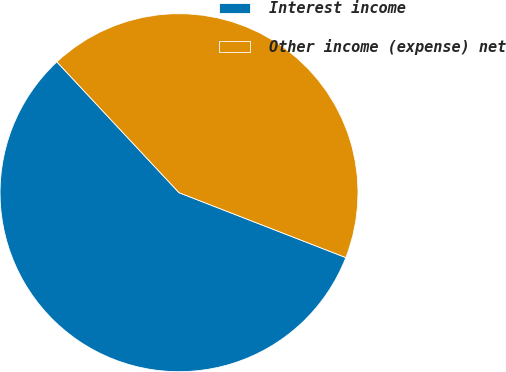Convert chart. <chart><loc_0><loc_0><loc_500><loc_500><pie_chart><fcel>Interest income<fcel>Other income (expense) net<nl><fcel>57.14%<fcel>42.86%<nl></chart> 